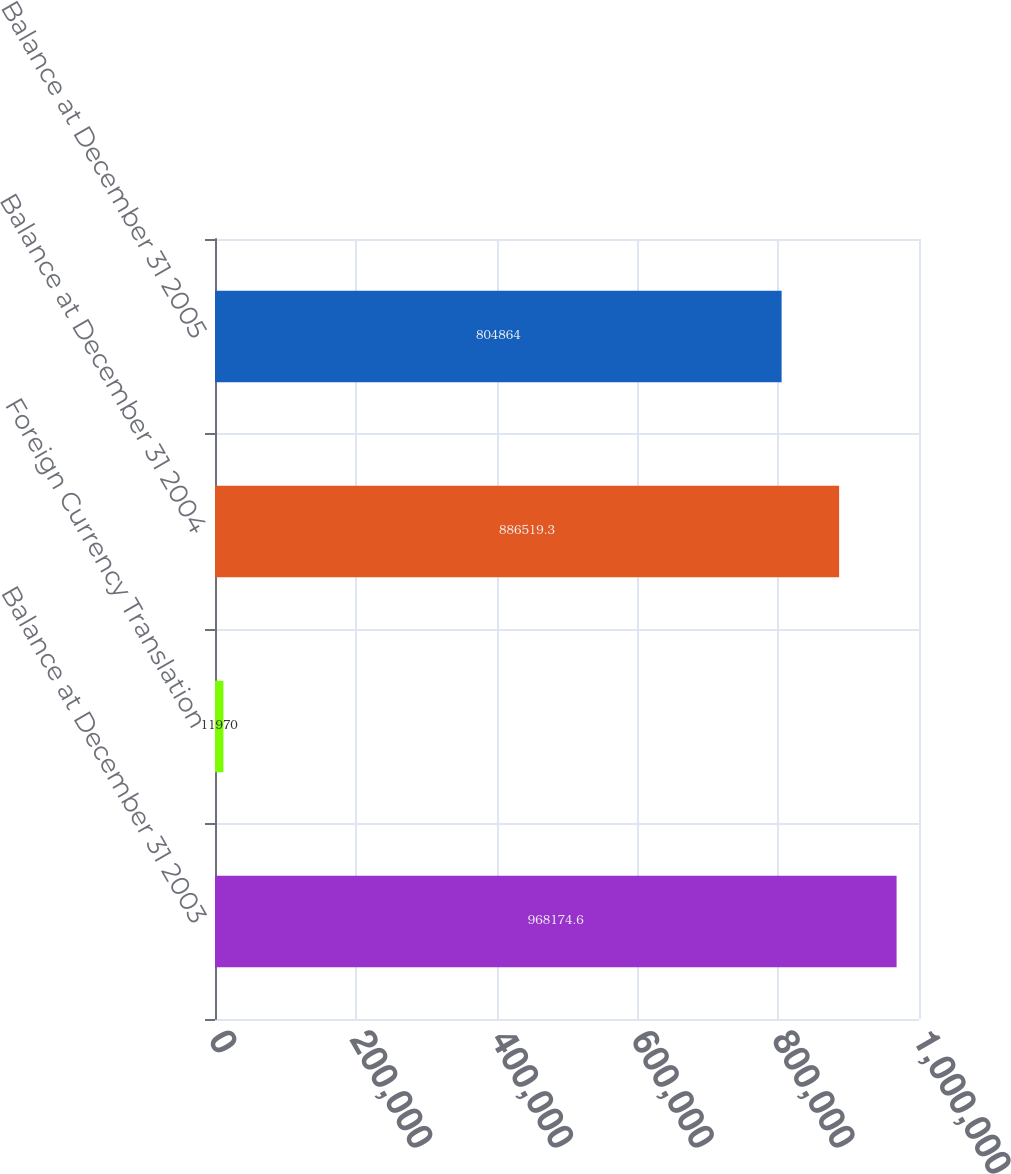Convert chart to OTSL. <chart><loc_0><loc_0><loc_500><loc_500><bar_chart><fcel>Balance at December 31 2003<fcel>Foreign Currency Translation<fcel>Balance at December 31 2004<fcel>Balance at December 31 2005<nl><fcel>968175<fcel>11970<fcel>886519<fcel>804864<nl></chart> 